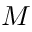Convert formula to latex. <formula><loc_0><loc_0><loc_500><loc_500>M</formula> 